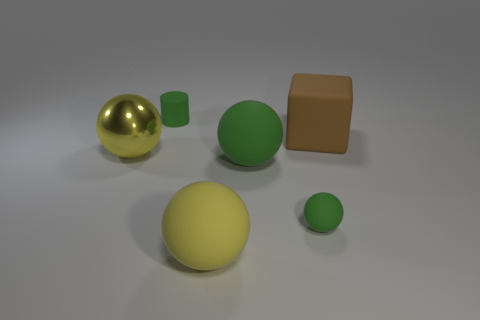What color is the shiny thing that is the same shape as the large yellow rubber object?
Offer a very short reply. Yellow. What is the size of the other green thing that is the same shape as the large green matte thing?
Make the answer very short. Small. What is the material of the small green thing right of the yellow matte ball?
Your response must be concise. Rubber. Are there fewer large rubber blocks to the left of the tiny green sphere than cylinders?
Provide a succinct answer. Yes. What shape is the large rubber thing behind the big yellow thing that is behind the yellow rubber object?
Offer a terse response. Cube. The small cylinder is what color?
Make the answer very short. Green. What number of other objects are there of the same size as the cylinder?
Ensure brevity in your answer.  1. The large thing that is behind the yellow rubber object and in front of the shiny ball is made of what material?
Your answer should be compact. Rubber. Does the matte object behind the block have the same size as the big metallic object?
Give a very brief answer. No. Is the color of the tiny cylinder the same as the small sphere?
Keep it short and to the point. Yes. 